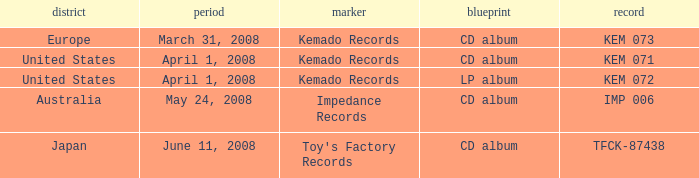Which Format has a Region of united states, and a Catalog of kem 072? LP album. 